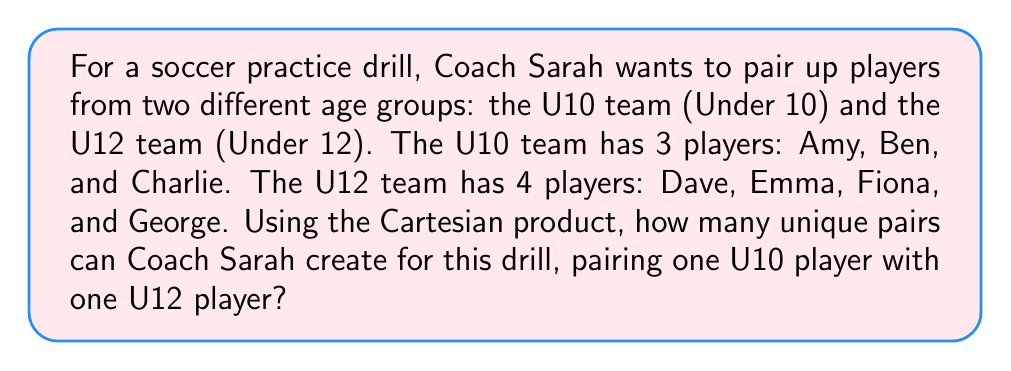Show me your answer to this math problem. To solve this problem, we need to understand the concept of Cartesian product and how it applies to pairing players from two different sets.

1. Let's define our sets:
   Set A (U10 team): $A = \{Amy, Ben, Charlie\}$
   Set B (U12 team): $B = \{Dave, Emma, Fiona, George\}$

2. The Cartesian product of sets A and B, denoted as $A \times B$, is the set of all ordered pairs $(a,b)$ where $a \in A$ and $b \in B$.

3. To visualize this, we can create a table:

   |       | Dave  | Emma  | Fiona | George |
   |-------|-------|-------|-------|--------|
   | Amy   | (A,D) | (A,E) | (A,F) | (A,G)  |
   | Ben   | (B,D) | (B,E) | (B,F) | (B,G)  |
   | Charlie| (C,D) | (C,E) | (C,F) | (C,G)  |

4. To calculate the number of unique pairs, we use the formula:
   $|A \times B| = |A| \times |B|$

   Where $|A|$ is the number of elements in set A, and $|B|$ is the number of elements in set B.

5. In this case:
   $|A| = 3$ (number of U10 players)
   $|B| = 4$ (number of U12 players)

6. Therefore, the number of unique pairs is:
   $|A \times B| = 3 \times 4 = 12$

This means Coach Sarah can create 12 different pairs for the practice drill, ensuring that each U10 player is paired with each U12 player once.
Answer: 12 unique pairs 